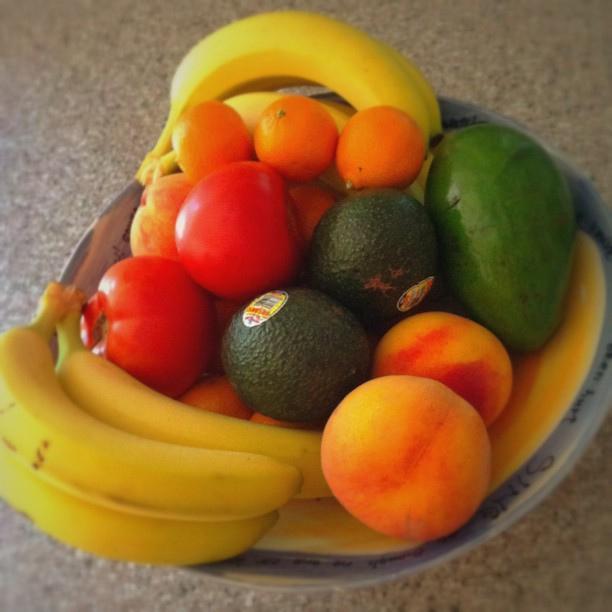How many oranges can you see?
Give a very brief answer. 3. How many bananas are there?
Give a very brief answer. 2. 